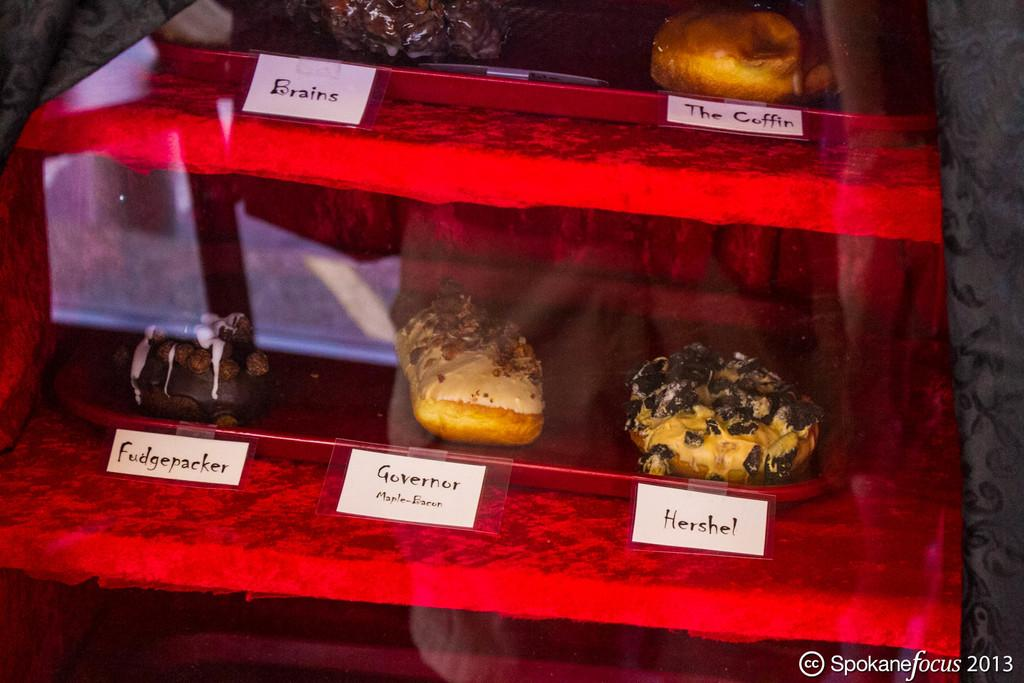<image>
Offer a succinct explanation of the picture presented. Objects for display on a red table including one that is named "Hershel". 